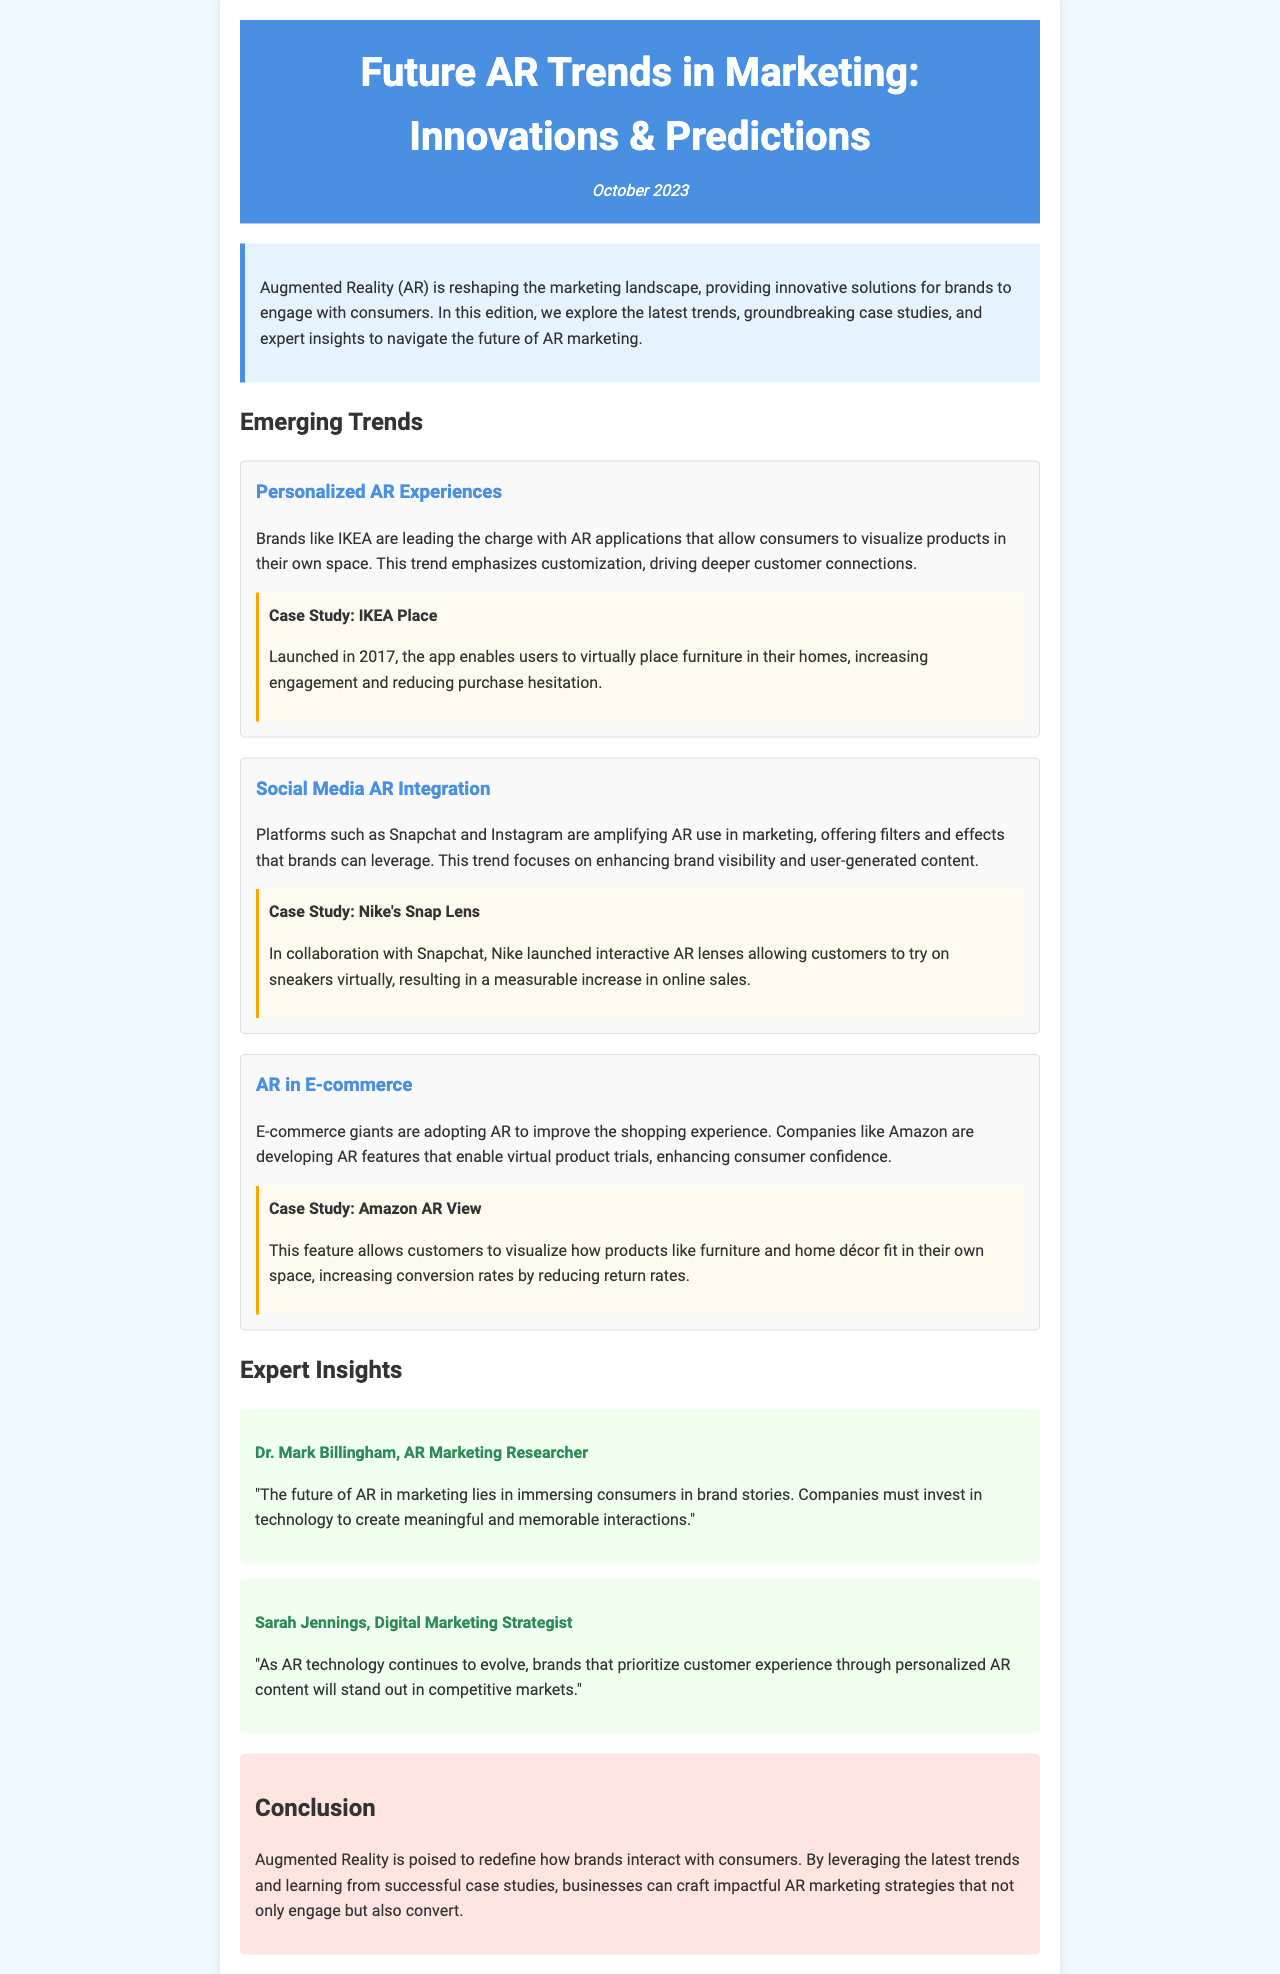What is the title of the newsletter? The title of the newsletter is the main heading displayed at the top of the document.
Answer: Future AR Trends in Marketing: Innovations & Predictions When was the newsletter published? The publication date appears under the title, indicating when the newsletter was released.
Answer: October 2023 Who is a featured expert in the newsletter? Experts are highlighted in their own sections, providing insights related to AR marketing.
Answer: Dr. Mark Billingham What AR application does IKEA offer? The case studies in the "Emerging Trends" section provide examples of brands and their AR solutions.
Answer: IKEA Place Which social media platform collaborated with Nike for an AR project? The document mentions specific case studies which involve social media collaboration.
Answer: Snapchat What is the main focus of the trend in AR in E-commerce? This trend highlights a specific use of AR technology within a particular marketing context.
Answer: Virtual product trials What statement does Sarah Jennings make about AR content? This quote reflects her beliefs regarding the future of brands and customer experience in AR marketing.
Answer: "Brands that prioritize customer experience through personalized AR content will stand out in competitive markets." What is a key benefit of AR according to the conclusion? The conclusion summarizes the overall impact of AR on brand-consumer interactions.
Answer: Engaging consumers What color is used for the header background? The document's style instructions indicate the color scheme for visual components.
Answer: #4a90e2 